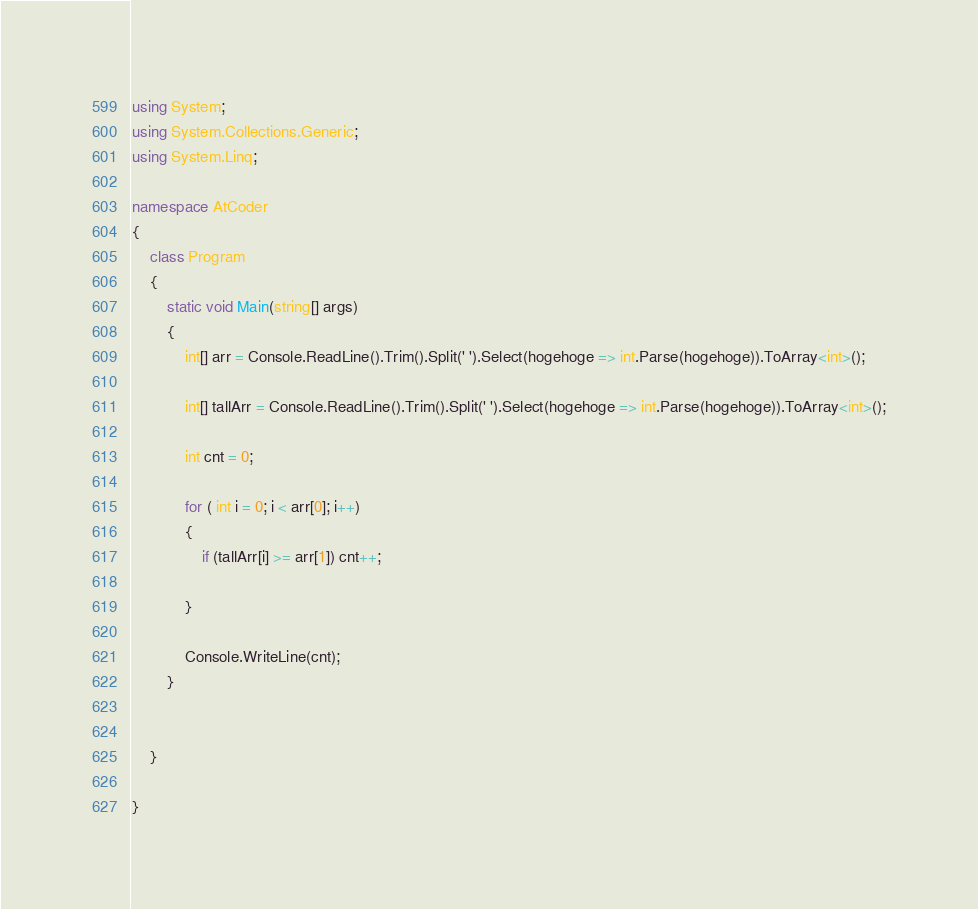Convert code to text. <code><loc_0><loc_0><loc_500><loc_500><_C#_>using System;
using System.Collections.Generic;
using System.Linq;

namespace AtCoder
{
	class Program
	{
		static void Main(string[] args)
		{
			int[] arr = Console.ReadLine().Trim().Split(' ').Select(hogehoge => int.Parse(hogehoge)).ToArray<int>();

			int[] tallArr = Console.ReadLine().Trim().Split(' ').Select(hogehoge => int.Parse(hogehoge)).ToArray<int>();

			int cnt = 0;

			for ( int i = 0; i < arr[0]; i++)
			{
				if (tallArr[i] >= arr[1]) cnt++;

			}

			Console.WriteLine(cnt);
		}


	}

}
</code> 